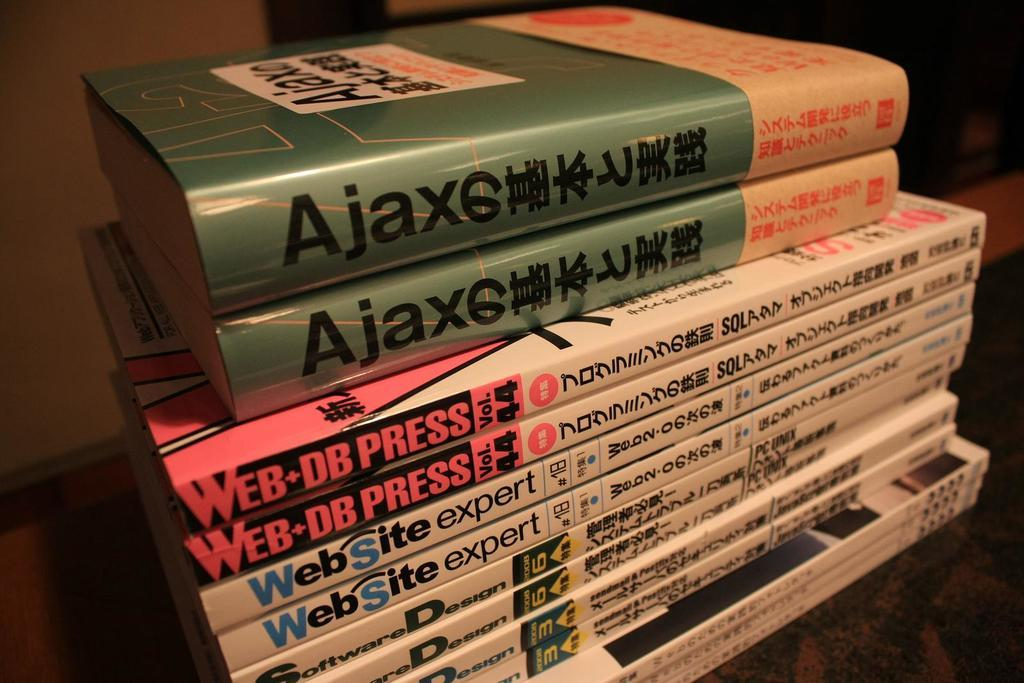Provide a one-sentence caption for the provided image. Several books are stacked up, including a few Web Site Expert books. 